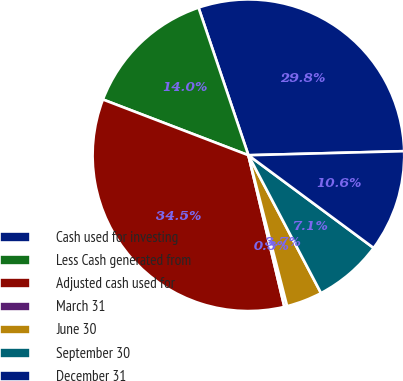<chart> <loc_0><loc_0><loc_500><loc_500><pie_chart><fcel>Cash used for investing<fcel>Less Cash generated from<fcel>Adjusted cash used for<fcel>March 31<fcel>June 30<fcel>September 30<fcel>December 31<nl><fcel>29.77%<fcel>13.99%<fcel>34.53%<fcel>0.29%<fcel>3.72%<fcel>7.14%<fcel>10.56%<nl></chart> 